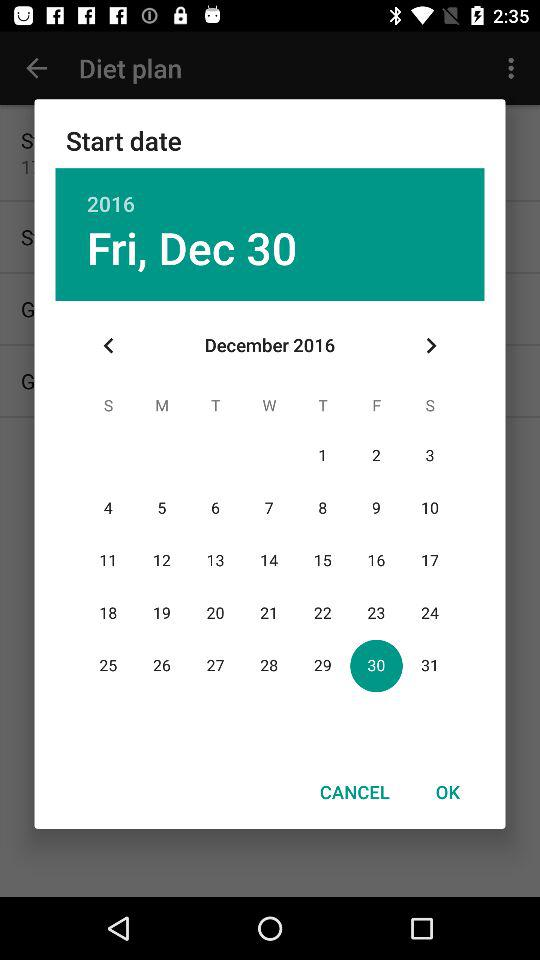Which date is selected in the calendar? The selected date is Friday, December 30, 2016. 